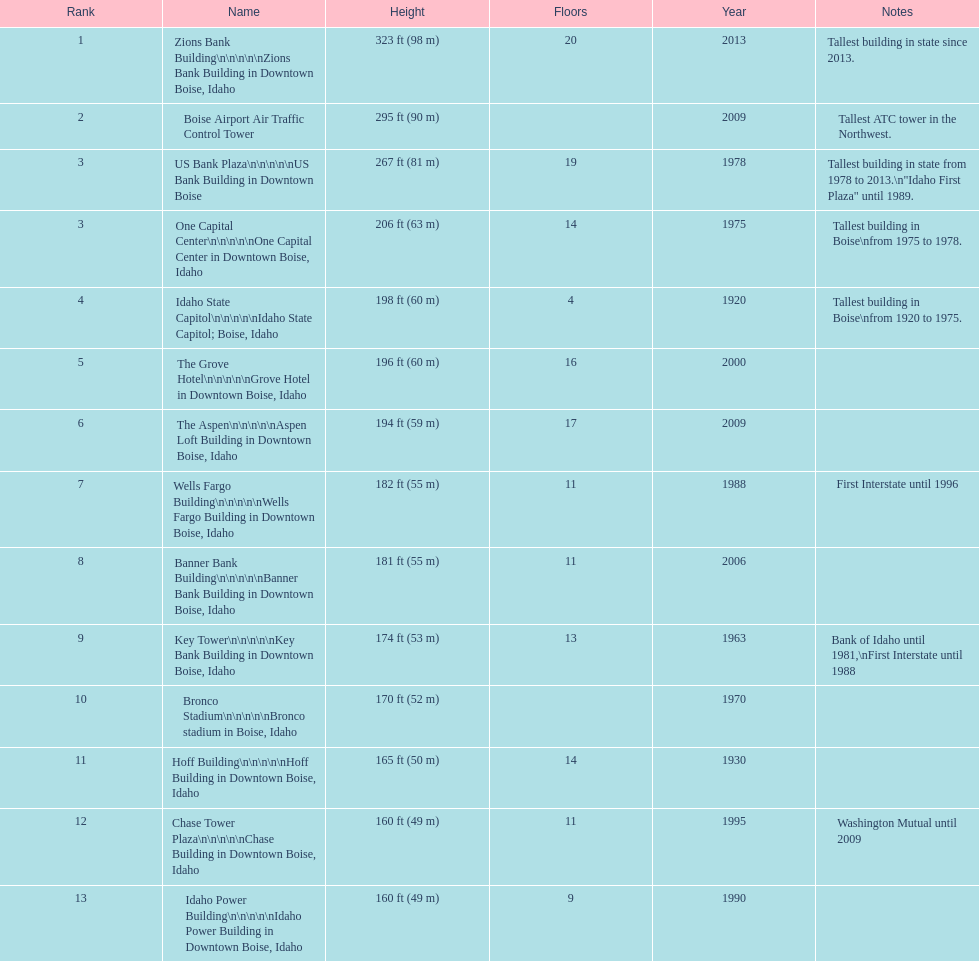What is the count of floors in the us bank plaza? 19. 